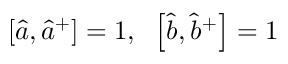Convert formula to latex. <formula><loc_0><loc_0><loc_500><loc_500>\left [ { \hat { a } } , { \hat { a } } ^ { + } \right ] = 1 , \, \left [ { \hat { b } } , { \hat { b } } ^ { + } \right ] = 1</formula> 